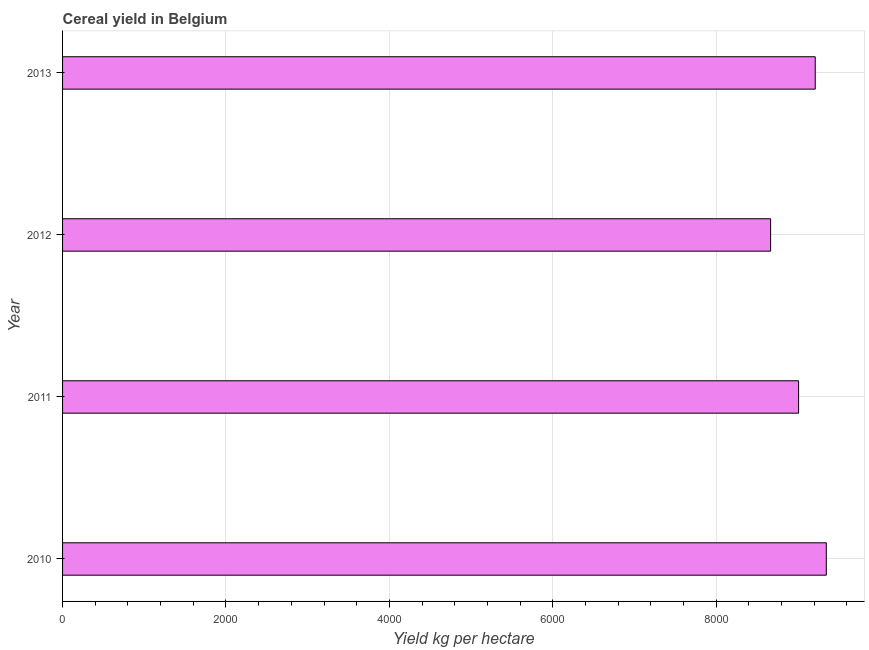Does the graph contain any zero values?
Your answer should be compact. No. Does the graph contain grids?
Your answer should be very brief. Yes. What is the title of the graph?
Offer a very short reply. Cereal yield in Belgium. What is the label or title of the X-axis?
Offer a terse response. Yield kg per hectare. What is the cereal yield in 2011?
Your answer should be very brief. 9008.98. Across all years, what is the maximum cereal yield?
Make the answer very short. 9348.08. Across all years, what is the minimum cereal yield?
Keep it short and to the point. 8666.29. In which year was the cereal yield maximum?
Your response must be concise. 2010. What is the sum of the cereal yield?
Your response must be concise. 3.62e+04. What is the difference between the cereal yield in 2012 and 2013?
Your answer should be compact. -546.26. What is the average cereal yield per year?
Your answer should be very brief. 9058.98. What is the median cereal yield?
Keep it short and to the point. 9110.76. In how many years, is the cereal yield greater than 7600 kg per hectare?
Your answer should be very brief. 4. Do a majority of the years between 2011 and 2010 (inclusive) have cereal yield greater than 8400 kg per hectare?
Provide a short and direct response. No. What is the ratio of the cereal yield in 2012 to that in 2013?
Your answer should be compact. 0.94. Is the cereal yield in 2012 less than that in 2013?
Provide a short and direct response. Yes. What is the difference between the highest and the second highest cereal yield?
Provide a succinct answer. 135.54. What is the difference between the highest and the lowest cereal yield?
Provide a short and direct response. 681.8. In how many years, is the cereal yield greater than the average cereal yield taken over all years?
Your answer should be very brief. 2. How many bars are there?
Ensure brevity in your answer.  4. What is the difference between two consecutive major ticks on the X-axis?
Make the answer very short. 2000. What is the Yield kg per hectare of 2010?
Offer a very short reply. 9348.08. What is the Yield kg per hectare in 2011?
Provide a succinct answer. 9008.98. What is the Yield kg per hectare of 2012?
Offer a very short reply. 8666.29. What is the Yield kg per hectare of 2013?
Your answer should be compact. 9212.55. What is the difference between the Yield kg per hectare in 2010 and 2011?
Give a very brief answer. 339.1. What is the difference between the Yield kg per hectare in 2010 and 2012?
Give a very brief answer. 681.79. What is the difference between the Yield kg per hectare in 2010 and 2013?
Offer a terse response. 135.54. What is the difference between the Yield kg per hectare in 2011 and 2012?
Provide a succinct answer. 342.7. What is the difference between the Yield kg per hectare in 2011 and 2013?
Provide a short and direct response. -203.56. What is the difference between the Yield kg per hectare in 2012 and 2013?
Make the answer very short. -546.26. What is the ratio of the Yield kg per hectare in 2010 to that in 2011?
Ensure brevity in your answer.  1.04. What is the ratio of the Yield kg per hectare in 2010 to that in 2012?
Keep it short and to the point. 1.08. What is the ratio of the Yield kg per hectare in 2011 to that in 2012?
Provide a short and direct response. 1.04. What is the ratio of the Yield kg per hectare in 2012 to that in 2013?
Your answer should be very brief. 0.94. 